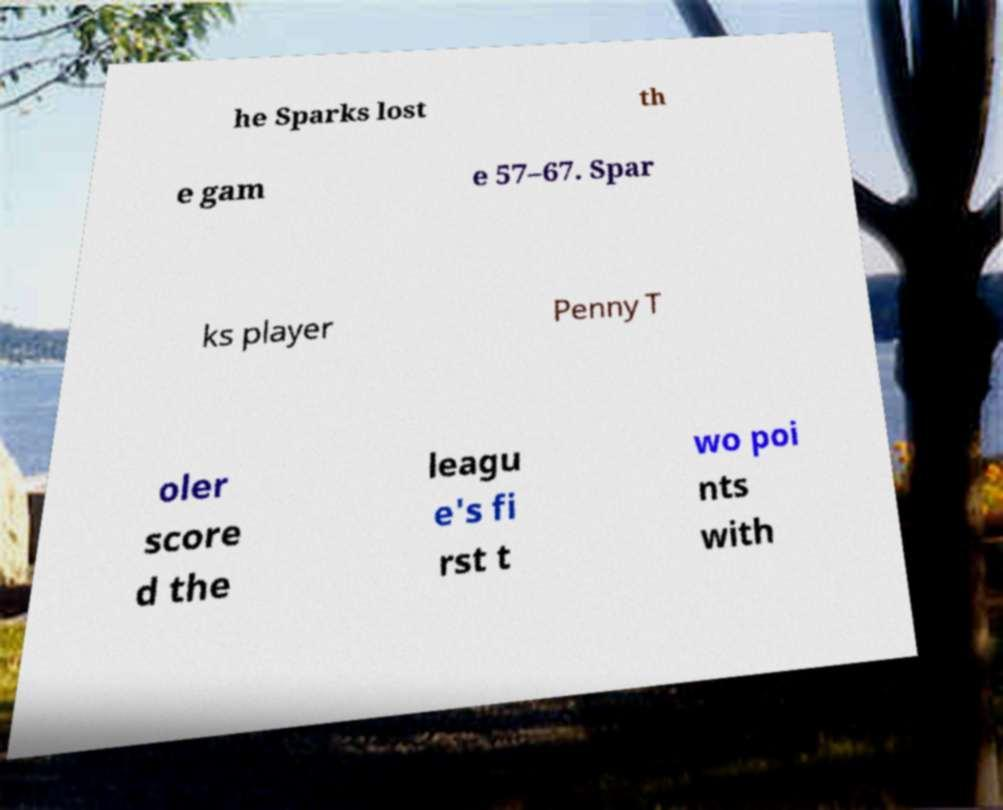Can you read and provide the text displayed in the image?This photo seems to have some interesting text. Can you extract and type it out for me? he Sparks lost th e gam e 57–67. Spar ks player Penny T oler score d the leagu e's fi rst t wo poi nts with 